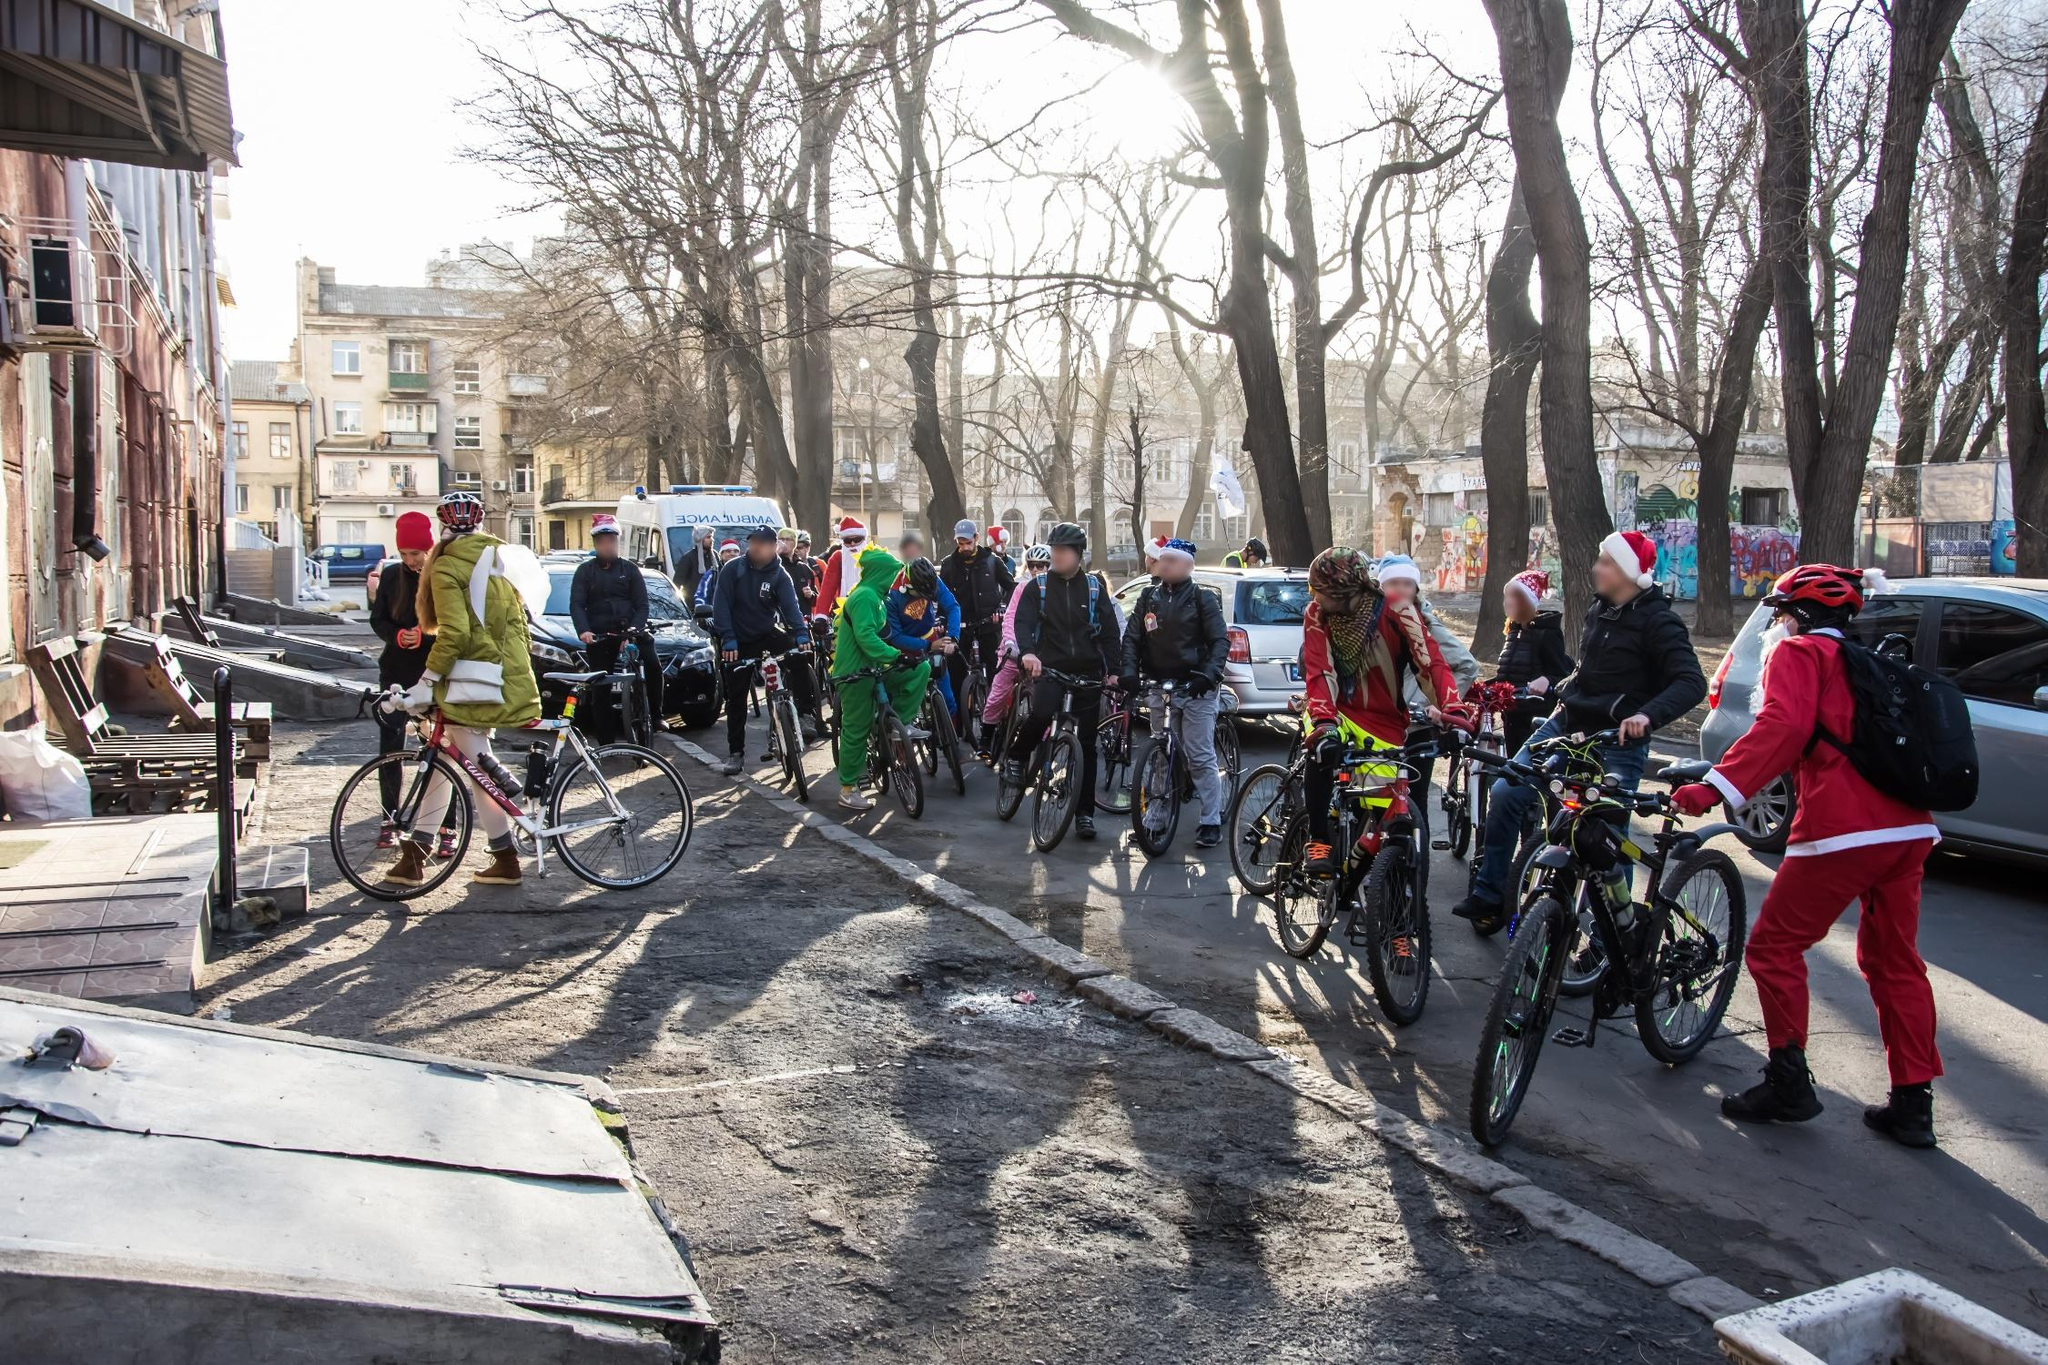Explain the visual content of the image in great detail. The image captures a vibrant and lively scene of a city street where a group of people is gathered, predominantly on bicycles. Many of the cyclists are dressed in festive costumes, prominently featuring Santa Claus attire and other colorful outfits in red, green, and other bright hues, suggesting a seasonal celebration, likely around Christmas. The urban setting is evident, with its buildings, parked cars, and leafless trees indicating a wintry atmosphere. The cyclists appear to be preparing for a communal ride, perhaps part of a festive event or a themed charity ride. The perspective of the image is from a low angle, amplifying the sense of activity and engagement as the cyclists are about to begin their journey. The road and surroundings show signs of the season with sparse sunlight breaking through the trees. This image is a snapshot of joy, community spirit, and festive cheer blending seamlessly into everyday urban life. 